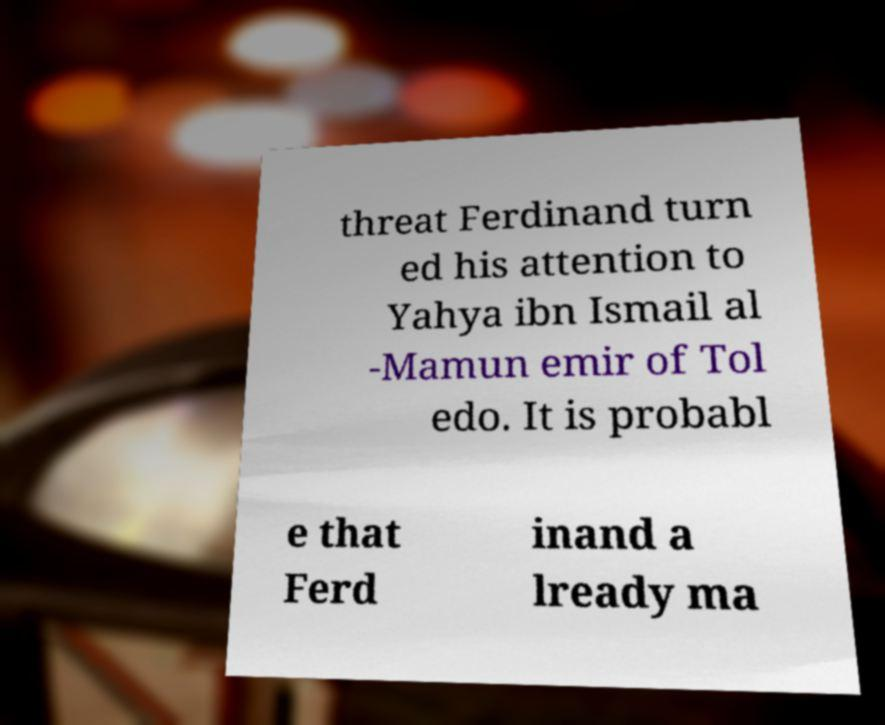Could you assist in decoding the text presented in this image and type it out clearly? threat Ferdinand turn ed his attention to Yahya ibn Ismail al -Mamun emir of Tol edo. It is probabl e that Ferd inand a lready ma 